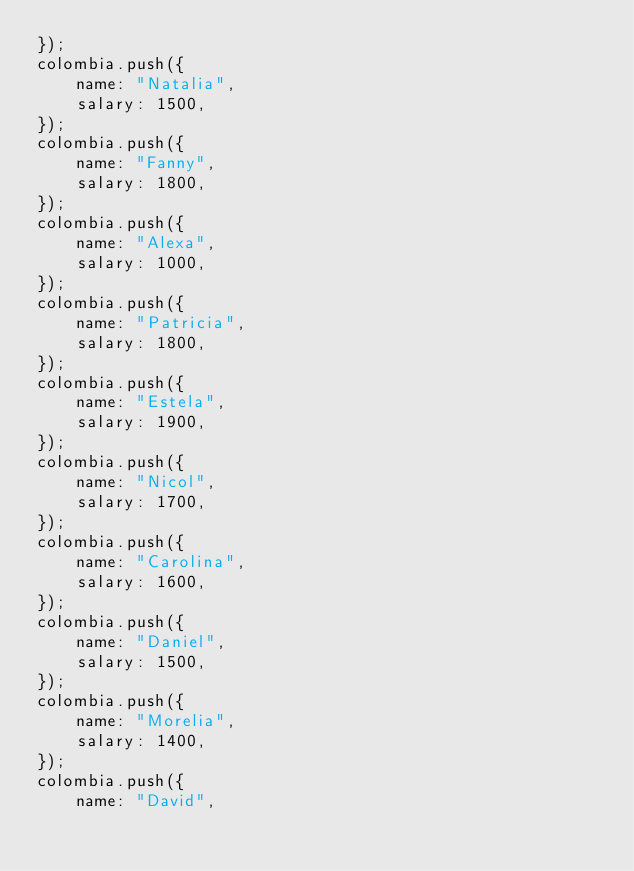<code> <loc_0><loc_0><loc_500><loc_500><_JavaScript_>});
colombia.push({
    name: "Natalia",
    salary: 1500,
});
colombia.push({
    name: "Fanny",
    salary: 1800,
});
colombia.push({
    name: "Alexa",
    salary: 1000,
});
colombia.push({
    name: "Patricia",
    salary: 1800,
});
colombia.push({
    name: "Estela",
    salary: 1900,
});
colombia.push({
    name: "Nicol",
    salary: 1700,
});
colombia.push({
    name: "Carolina",
    salary: 1600,
});
colombia.push({
    name: "Daniel",
    salary: 1500,
});
colombia.push({
    name: "Morelia",
    salary: 1400,
});
colombia.push({
    name: "David",</code> 